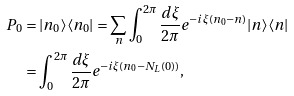Convert formula to latex. <formula><loc_0><loc_0><loc_500><loc_500>P _ { 0 } & = | n _ { 0 } \rangle \langle n _ { 0 } | = \sum _ { n } \int _ { 0 } ^ { 2 \pi } \frac { d \xi } { 2 \pi } e ^ { - i \xi ( n _ { 0 } - n ) } | n \rangle \langle n | \\ & = \int _ { 0 } ^ { 2 \pi } \frac { d \xi } { 2 \pi } e ^ { - i \xi ( n _ { 0 } - N _ { L } ( 0 ) ) } ,</formula> 